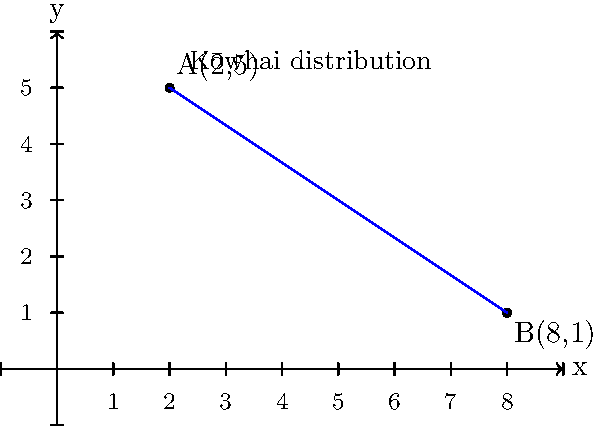As part of a project integrating Māori knowledge into modern scientific research, you're mapping the distribution of kōwhai, a native New Zealand tree species. Two significant kōwhai stands are located at points A(2,5) and B(8,1) on a coordinate grid, where each unit represents 1 km. Calculate the direct distance between these two kōwhai stands to the nearest tenth of a kilometer. To find the distance between two points on a coordinate plane, we can use the distance formula, which is derived from the Pythagorean theorem:

Distance = $\sqrt{(x_2-x_1)^2 + (y_2-y_1)^2}$

Where $(x_1,y_1)$ are the coordinates of the first point and $(x_2,y_2)$ are the coordinates of the second point.

Let's solve this step-by-step:

1) We have point A(2,5) and point B(8,1)
   So, $(x_1,y_1) = (2,5)$ and $(x_2,y_2) = (8,1)$

2) Let's plug these into the formula:
   Distance = $\sqrt{(8-2)^2 + (1-5)^2}$

3) Simplify inside the parentheses:
   Distance = $\sqrt{6^2 + (-4)^2}$

4) Calculate the squares:
   Distance = $\sqrt{36 + 16}$

5) Add under the square root:
   Distance = $\sqrt{52}$

6) Simplify the square root:
   Distance = $\sqrt{4 * 13} = 2\sqrt{13}$

7) Use a calculator to approximate and round to the nearest tenth:
   Distance ≈ 7.2 km

This result represents the direct distance between the two kōwhai stands in kilometers.
Answer: 7.2 km 